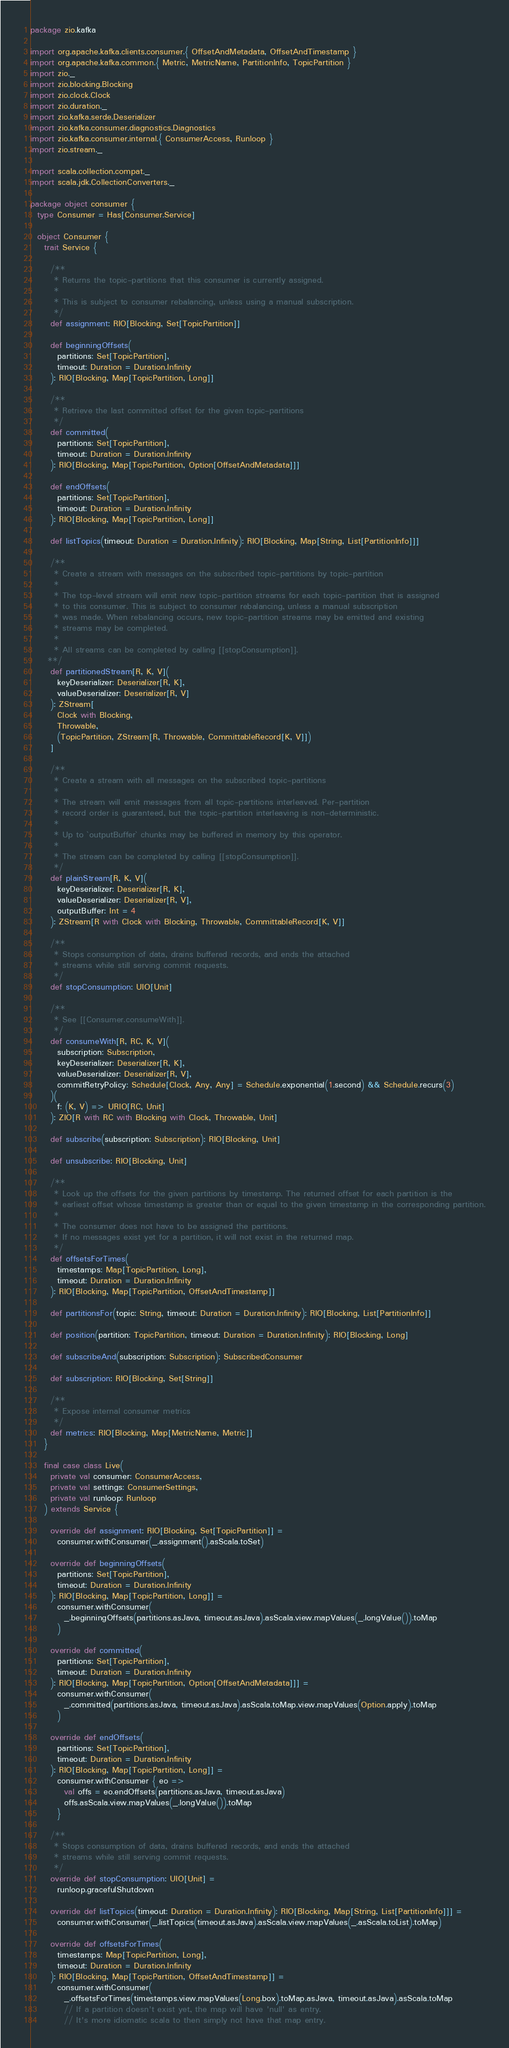Convert code to text. <code><loc_0><loc_0><loc_500><loc_500><_Scala_>package zio.kafka

import org.apache.kafka.clients.consumer.{ OffsetAndMetadata, OffsetAndTimestamp }
import org.apache.kafka.common.{ Metric, MetricName, PartitionInfo, TopicPartition }
import zio._
import zio.blocking.Blocking
import zio.clock.Clock
import zio.duration._
import zio.kafka.serde.Deserializer
import zio.kafka.consumer.diagnostics.Diagnostics
import zio.kafka.consumer.internal.{ ConsumerAccess, Runloop }
import zio.stream._

import scala.collection.compat._
import scala.jdk.CollectionConverters._

package object consumer {
  type Consumer = Has[Consumer.Service]

  object Consumer {
    trait Service {

      /**
       * Returns the topic-partitions that this consumer is currently assigned.
       *
       * This is subject to consumer rebalancing, unless using a manual subscription.
       */
      def assignment: RIO[Blocking, Set[TopicPartition]]

      def beginningOffsets(
        partitions: Set[TopicPartition],
        timeout: Duration = Duration.Infinity
      ): RIO[Blocking, Map[TopicPartition, Long]]

      /**
       * Retrieve the last committed offset for the given topic-partitions
       */
      def committed(
        partitions: Set[TopicPartition],
        timeout: Duration = Duration.Infinity
      ): RIO[Blocking, Map[TopicPartition, Option[OffsetAndMetadata]]]

      def endOffsets(
        partitions: Set[TopicPartition],
        timeout: Duration = Duration.Infinity
      ): RIO[Blocking, Map[TopicPartition, Long]]

      def listTopics(timeout: Duration = Duration.Infinity): RIO[Blocking, Map[String, List[PartitionInfo]]]

      /**
       * Create a stream with messages on the subscribed topic-partitions by topic-partition
       *
       * The top-level stream will emit new topic-partition streams for each topic-partition that is assigned
       * to this consumer. This is subject to consumer rebalancing, unless a manual subscription
       * was made. When rebalancing occurs, new topic-partition streams may be emitted and existing
       * streams may be completed.
       *
       * All streams can be completed by calling [[stopConsumption]].
     **/
      def partitionedStream[R, K, V](
        keyDeserializer: Deserializer[R, K],
        valueDeserializer: Deserializer[R, V]
      ): ZStream[
        Clock with Blocking,
        Throwable,
        (TopicPartition, ZStream[R, Throwable, CommittableRecord[K, V]])
      ]

      /**
       * Create a stream with all messages on the subscribed topic-partitions
       *
       * The stream will emit messages from all topic-partitions interleaved. Per-partition
       * record order is guaranteed, but the topic-partition interleaving is non-deterministic.
       *
       * Up to `outputBuffer` chunks may be buffered in memory by this operator.
       *
       * The stream can be completed by calling [[stopConsumption]].
       */
      def plainStream[R, K, V](
        keyDeserializer: Deserializer[R, K],
        valueDeserializer: Deserializer[R, V],
        outputBuffer: Int = 4
      ): ZStream[R with Clock with Blocking, Throwable, CommittableRecord[K, V]]

      /**
       * Stops consumption of data, drains buffered records, and ends the attached
       * streams while still serving commit requests.
       */
      def stopConsumption: UIO[Unit]

      /**
       * See [[Consumer.consumeWith]].
       */
      def consumeWith[R, RC, K, V](
        subscription: Subscription,
        keyDeserializer: Deserializer[R, K],
        valueDeserializer: Deserializer[R, V],
        commitRetryPolicy: Schedule[Clock, Any, Any] = Schedule.exponential(1.second) && Schedule.recurs(3)
      )(
        f: (K, V) => URIO[RC, Unit]
      ): ZIO[R with RC with Blocking with Clock, Throwable, Unit]

      def subscribe(subscription: Subscription): RIO[Blocking, Unit]

      def unsubscribe: RIO[Blocking, Unit]

      /**
       * Look up the offsets for the given partitions by timestamp. The returned offset for each partition is the
       * earliest offset whose timestamp is greater than or equal to the given timestamp in the corresponding partition.
       *
       * The consumer does not have to be assigned the partitions.
       * If no messages exist yet for a partition, it will not exist in the returned map.
       */
      def offsetsForTimes(
        timestamps: Map[TopicPartition, Long],
        timeout: Duration = Duration.Infinity
      ): RIO[Blocking, Map[TopicPartition, OffsetAndTimestamp]]

      def partitionsFor(topic: String, timeout: Duration = Duration.Infinity): RIO[Blocking, List[PartitionInfo]]

      def position(partition: TopicPartition, timeout: Duration = Duration.Infinity): RIO[Blocking, Long]

      def subscribeAnd(subscription: Subscription): SubscribedConsumer

      def subscription: RIO[Blocking, Set[String]]

      /**
       * Expose internal consumer metrics
       */
      def metrics: RIO[Blocking, Map[MetricName, Metric]]
    }

    final case class Live(
      private val consumer: ConsumerAccess,
      private val settings: ConsumerSettings,
      private val runloop: Runloop
    ) extends Service {

      override def assignment: RIO[Blocking, Set[TopicPartition]] =
        consumer.withConsumer(_.assignment().asScala.toSet)

      override def beginningOffsets(
        partitions: Set[TopicPartition],
        timeout: Duration = Duration.Infinity
      ): RIO[Blocking, Map[TopicPartition, Long]] =
        consumer.withConsumer(
          _.beginningOffsets(partitions.asJava, timeout.asJava).asScala.view.mapValues(_.longValue()).toMap
        )

      override def committed(
        partitions: Set[TopicPartition],
        timeout: Duration = Duration.Infinity
      ): RIO[Blocking, Map[TopicPartition, Option[OffsetAndMetadata]]] =
        consumer.withConsumer(
          _.committed(partitions.asJava, timeout.asJava).asScala.toMap.view.mapValues(Option.apply).toMap
        )

      override def endOffsets(
        partitions: Set[TopicPartition],
        timeout: Duration = Duration.Infinity
      ): RIO[Blocking, Map[TopicPartition, Long]] =
        consumer.withConsumer { eo =>
          val offs = eo.endOffsets(partitions.asJava, timeout.asJava)
          offs.asScala.view.mapValues(_.longValue()).toMap
        }

      /**
       * Stops consumption of data, drains buffered records, and ends the attached
       * streams while still serving commit requests.
       */
      override def stopConsumption: UIO[Unit] =
        runloop.gracefulShutdown

      override def listTopics(timeout: Duration = Duration.Infinity): RIO[Blocking, Map[String, List[PartitionInfo]]] =
        consumer.withConsumer(_.listTopics(timeout.asJava).asScala.view.mapValues(_.asScala.toList).toMap)

      override def offsetsForTimes(
        timestamps: Map[TopicPartition, Long],
        timeout: Duration = Duration.Infinity
      ): RIO[Blocking, Map[TopicPartition, OffsetAndTimestamp]] =
        consumer.withConsumer(
          _.offsetsForTimes(timestamps.view.mapValues(Long.box).toMap.asJava, timeout.asJava).asScala.toMap
          // If a partition doesn't exist yet, the map will have 'null' as entry.
          // It's more idiomatic scala to then simply not have that map entry.</code> 